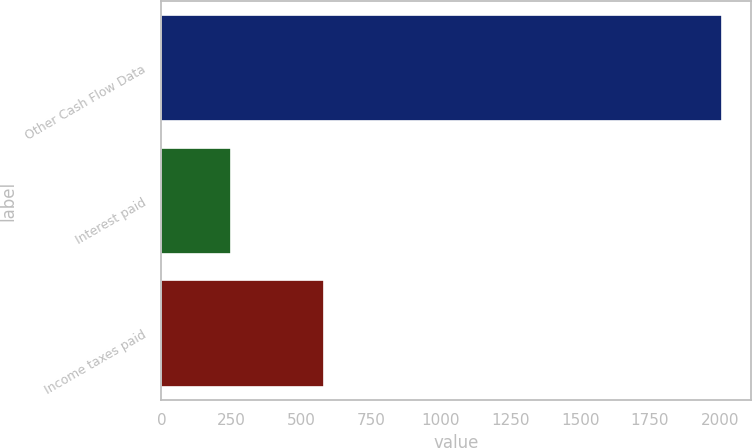Convert chart. <chart><loc_0><loc_0><loc_500><loc_500><bar_chart><fcel>Other Cash Flow Data<fcel>Interest paid<fcel>Income taxes paid<nl><fcel>2010<fcel>248<fcel>582<nl></chart> 